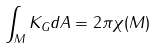Convert formula to latex. <formula><loc_0><loc_0><loc_500><loc_500>\int _ { M } K _ { G } d A = 2 \pi \chi ( M )</formula> 